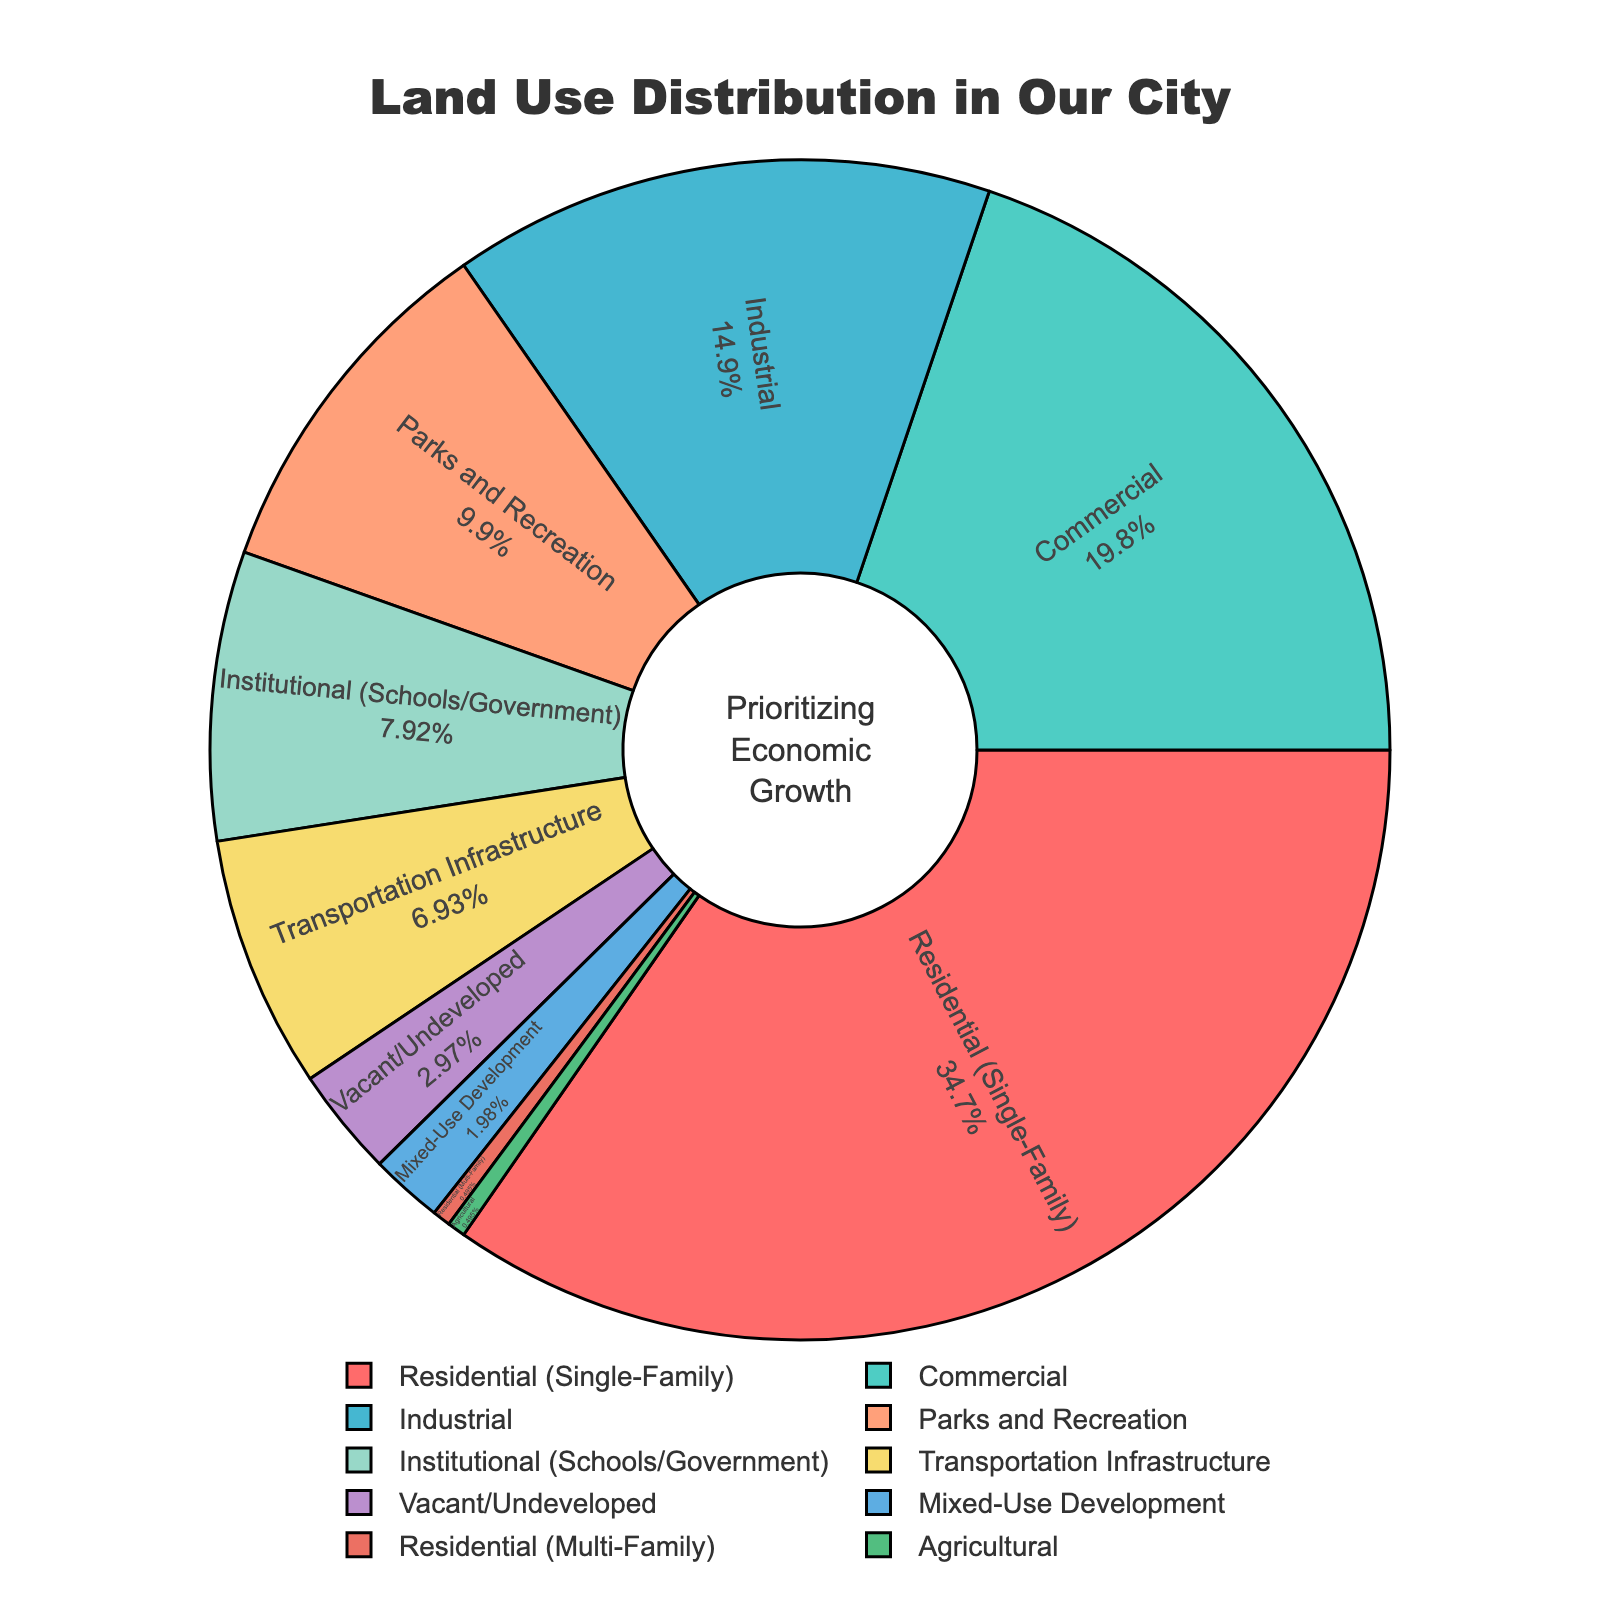Which land use category occupies the largest percentage within city limits? From the pie chart, the largest segment is for Residential (Single-Family), which has the highest percentage.
Answer: Residential (Single-Family) Which land use categories together occupy 30% of the city's land? Based on the chart, if you sum Commercial (20%) and Parks and Recreation (10%), you get 30%.
Answer: Commercial, Parks and Recreation Which is smaller: the percentage of land used for Industrial purposes or Residential (Multi-Family) and Agricultural combined? Residential (Multi-Family) and Agricultural combined is 0.5% + 0.5% = 1%, which is less than Industrial (15%).
Answer: Residential (Multi-Family) and Agricultural combined How much more land is used for Institutional than Mixed-Use Development? Institutional (Schools/Government) is 8%, while Mixed-Use Development is 2%, so the difference is 8% - 2% = 6%.
Answer: 6% What is the total percentage of land that is either vacant/undeveloped or used for transportation infrastructure? Vacant/Undeveloped is 3% and Transportation Infrastructure is 7%. Summing these gives 3% + 7% = 10%.
Answer: 10% Which category uses more land: Commercial or Industrial? From the pie chart, Commercial uses 20% and Industrial uses 15%. Therefore, Commercial uses more land.
Answer: Commercial What percentage of land is used for all residential purposes combined? Residential (Single-Family) is 35% and Residential (Multi-Family) is 0.5%. Summing these gives 35% + 0.5% = 35.5%.
Answer: 35.5% Is the land used for Parks and Recreation greater than that used for Institutional purposes? Parks and Recreation use 10%, and Institutional uses 8%. Thus, Parks and Recreation use more land.
Answer: Yes What is the average percentage of land use for Parks and Recreation, Institutional, and Vacant/Undeveloped categories? Parks and Recreation is 10%, Institutional is 8%, and Vacant/Undeveloped is 3%. The sum is 10% + 8% + 3% = 21%. The average is 21% / 3 = 7%.
Answer: 7% Which category has the smallest land allocation, and what is the percentage? Based on the pie chart, Residential (Multi-Family) and Agricultural both have the smallest allocation at 0.5% each.
Answer: Residential (Multi-Family), Agricultural 